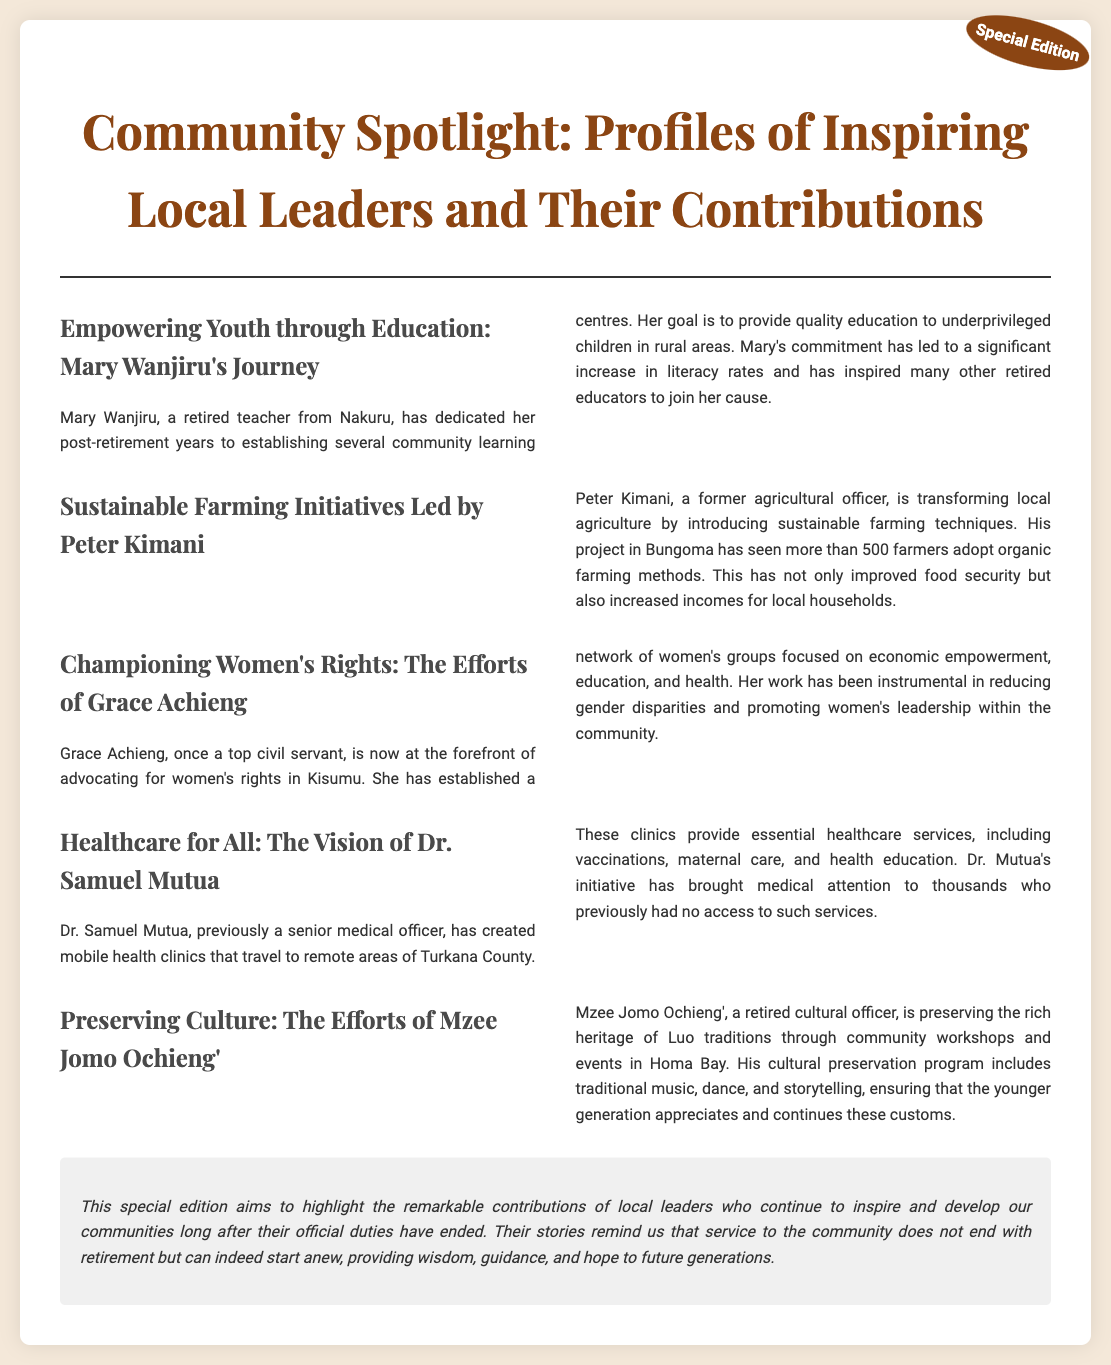What is the title of the document? The title is stated at the top of the document in a prominent font.
Answer: Community Spotlight: Profiles of Inspiring Local Leaders and Their Contributions Who is the retired teacher from Nakuru? The document introduces various local leaders, focusing on their contributions; Mary Wanjiru is notably mentioned.
Answer: Mary Wanjiru How many farmers have adopted organic farming methods? Peter Kimani's project statistics are provided in the text, highlighting the number of farmers involved.
Answer: More than 500 farmers What is Dr. Samuel Mutua's initiative focused on? The document discusses his mobile health clinics which provide several services.
Answer: Healthcare services Which community's traditions is Mzee Jomo Ochieng' preserving? The document explicitly mentions the specific community whose heritage he is focused on preserving.
Answer: Luo traditions What is the purpose of the editorial note? The editorial note summarizes the intent of the special edition and the themes discussed throughout the document.
Answer: Highlight the contributions of local leaders What type of empowerment does Grace Achieng focus on? The document elaborates on her work with women's groups which encompasses multiple areas of focus.
Answer: Economic empowerment In which county does Dr. Samuel Mutua provide health services? The text specifies the location where Dr. Mutua's mobile clinics operate, providing context to his work.
Answer: Turkana County 